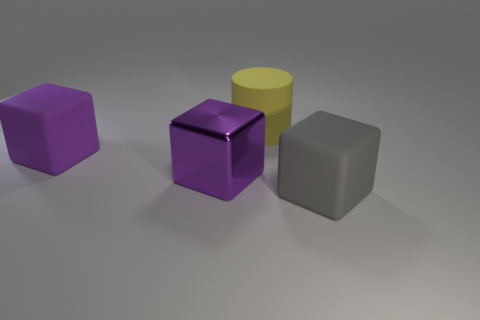What material do the objects in the image look like they're made of? The objects in the image seem to be made of distinct materials. The purple and light purple objects have a matte finish suggesting a plastic or painted wood material, while the yellow cylinder looks like it could be made of a polished metal or a plastic with a metallic finish. The gray cube has a nondescript, rough texture indicative of a rubber material. 